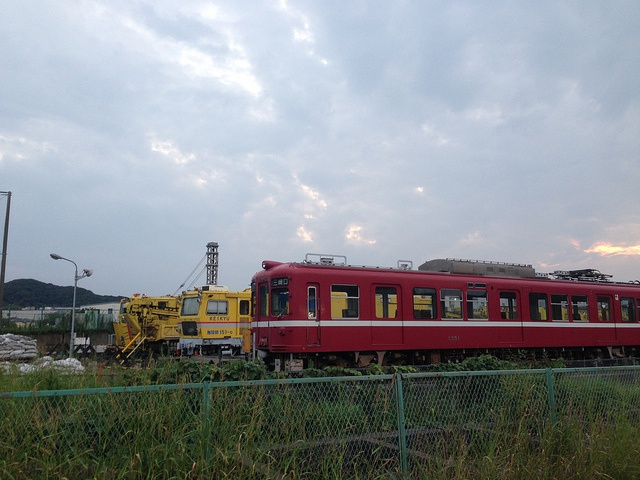Describe the objects in this image and their specific colors. I can see a train in lightgray, maroon, black, darkgray, and gray tones in this image. 